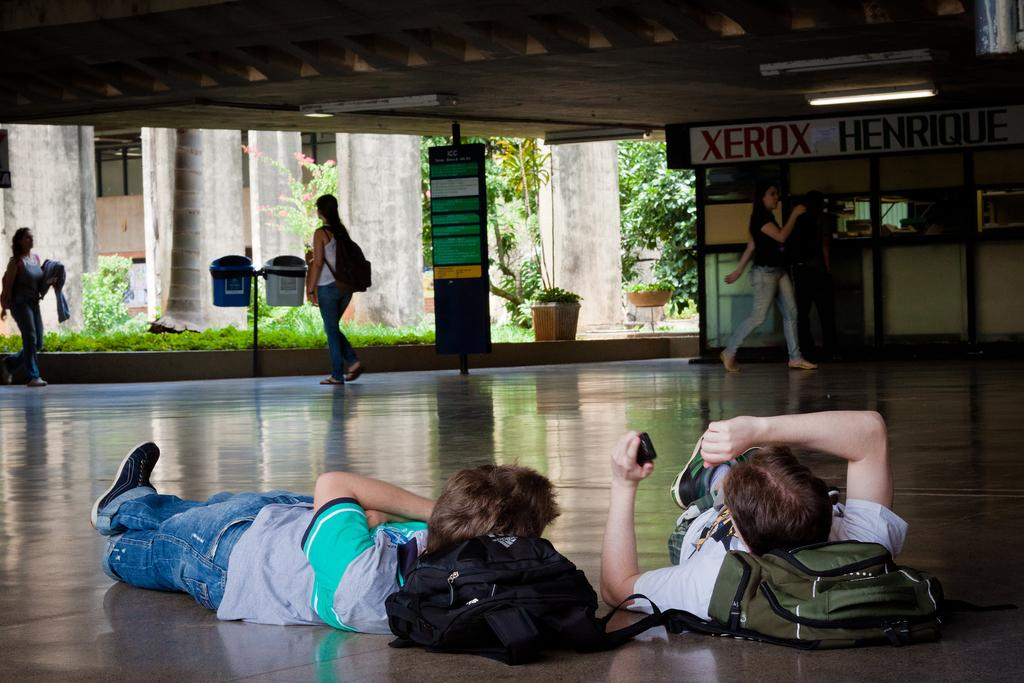<image>
Summarize the visual content of the image. Two guys are lying on the ground with their backpacks as pillows inside a building with a sign of Xerox in the back. 